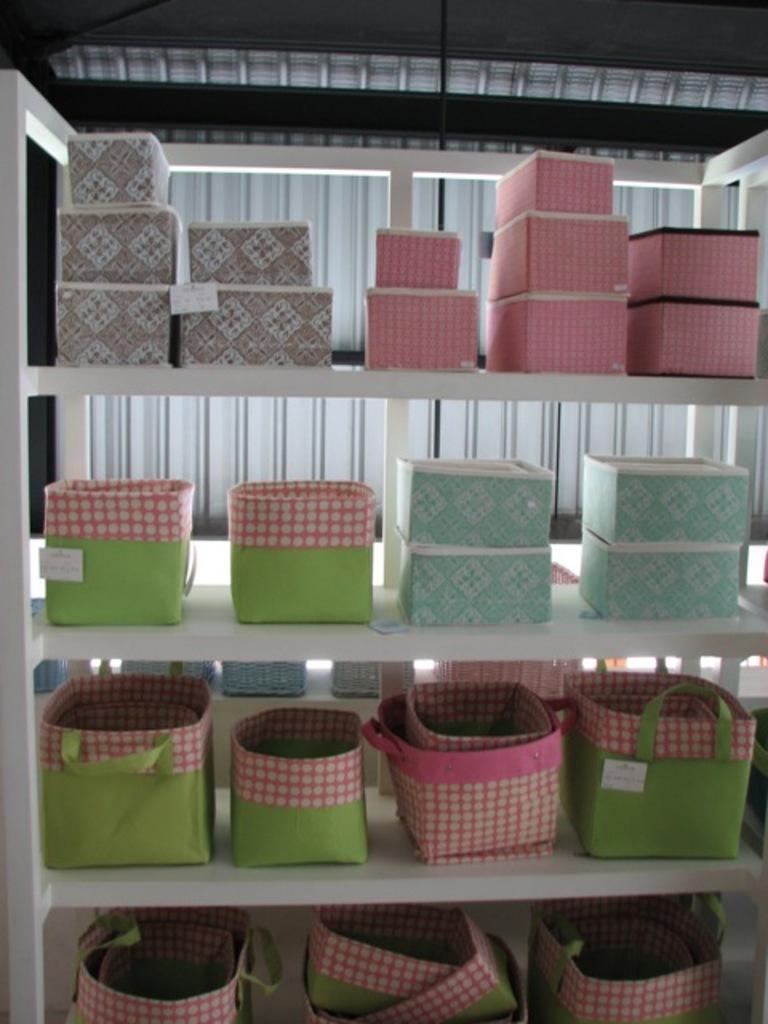How would you summarize this image in a sentence or two? In this picture we can see few boxes and bags in the racks. 